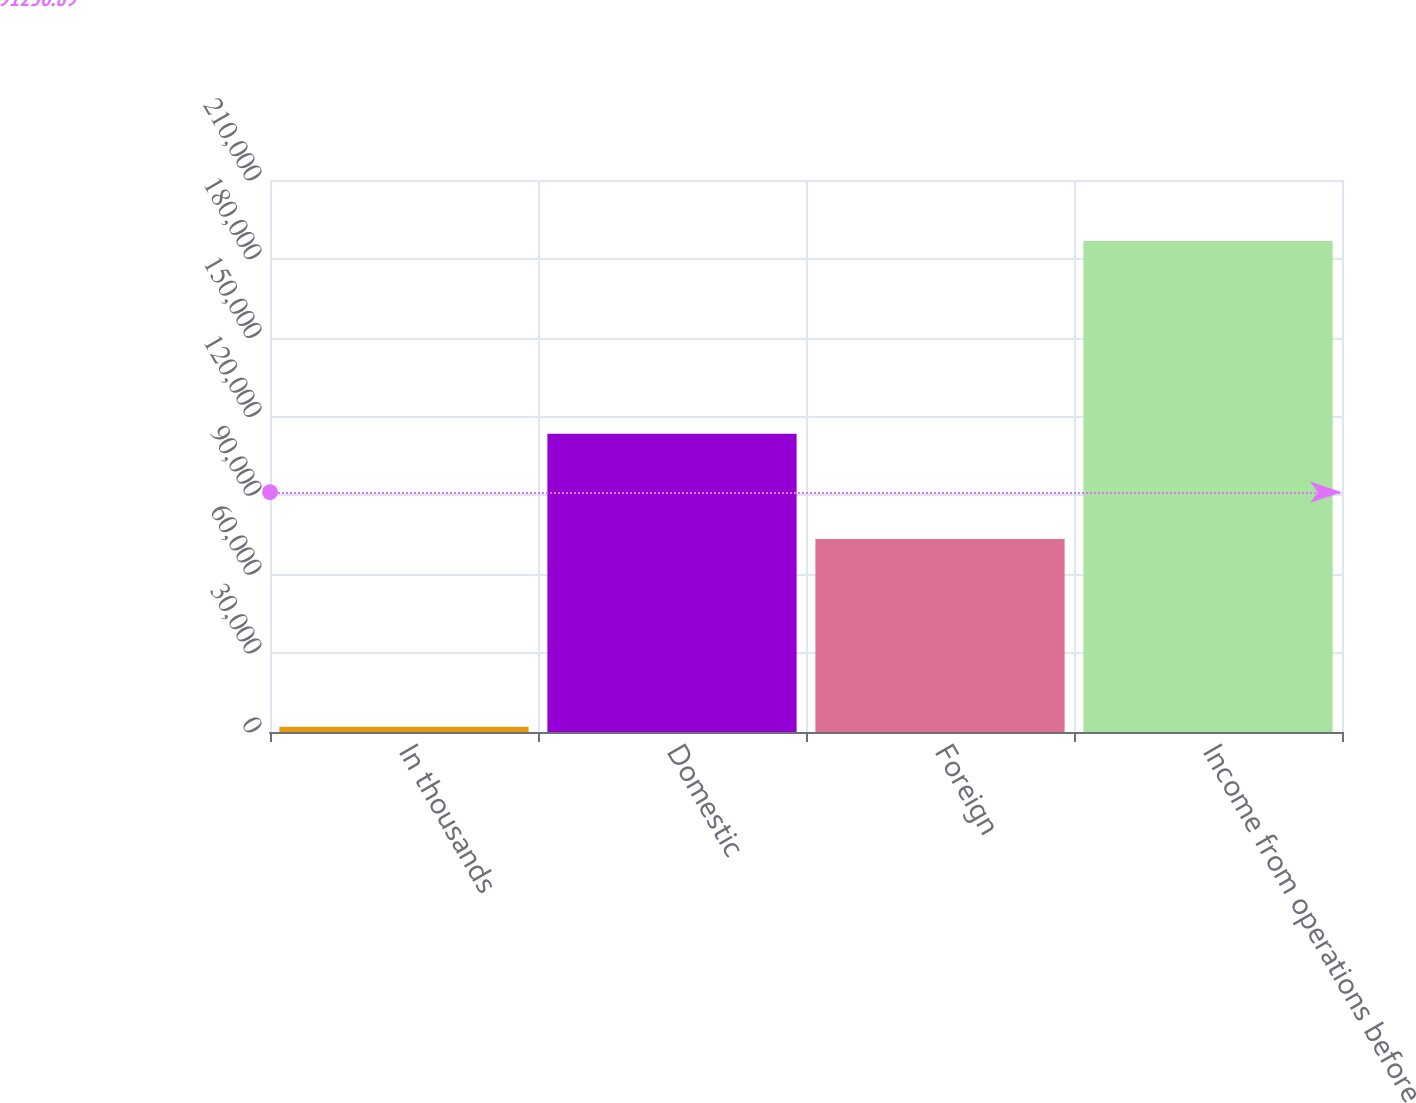Convert chart. <chart><loc_0><loc_0><loc_500><loc_500><bar_chart><fcel>In thousands<fcel>Domestic<fcel>Foreign<fcel>Income from operations before<nl><fcel>2010<fcel>113430<fcel>73397<fcel>186827<nl></chart> 